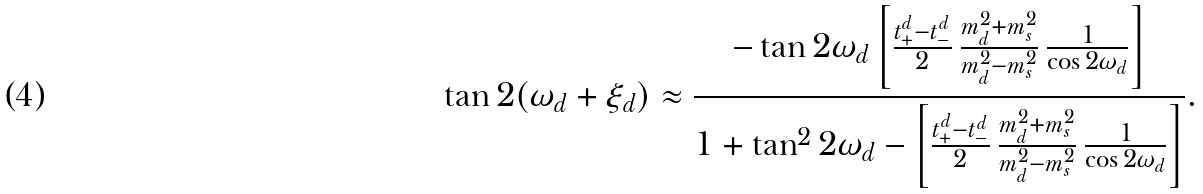Convert formula to latex. <formula><loc_0><loc_0><loc_500><loc_500>\tan 2 ( \omega _ { d } + \xi _ { d } ) \approx \frac { - \tan 2 \omega _ { d } \left [ \frac { t _ { + } ^ { d } - t _ { - } ^ { d } } { 2 } \, \frac { m _ { d } ^ { 2 } + m _ { s } ^ { 2 } } { m _ { d } ^ { 2 } - m _ { s } ^ { 2 } } \, \frac { 1 } { \cos 2 \omega _ { d } } \right ] } { 1 + \tan ^ { 2 } 2 \omega _ { d } - \left [ \frac { t _ { + } ^ { d } - t _ { - } ^ { d } } { 2 } \, \frac { m _ { d } ^ { 2 } + m _ { s } ^ { 2 } } { m _ { d } ^ { 2 } - m _ { s } ^ { 2 } } \, \frac { 1 } { \cos 2 \omega _ { d } } \right ] } .</formula> 